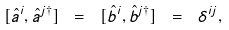<formula> <loc_0><loc_0><loc_500><loc_500>[ \hat { a } ^ { i } , \hat { a } ^ { j \dagger } ] \ = \ [ \hat { b } ^ { i } , \hat { b } ^ { j \dagger } ] \ = \ \delta ^ { i j } ,</formula> 